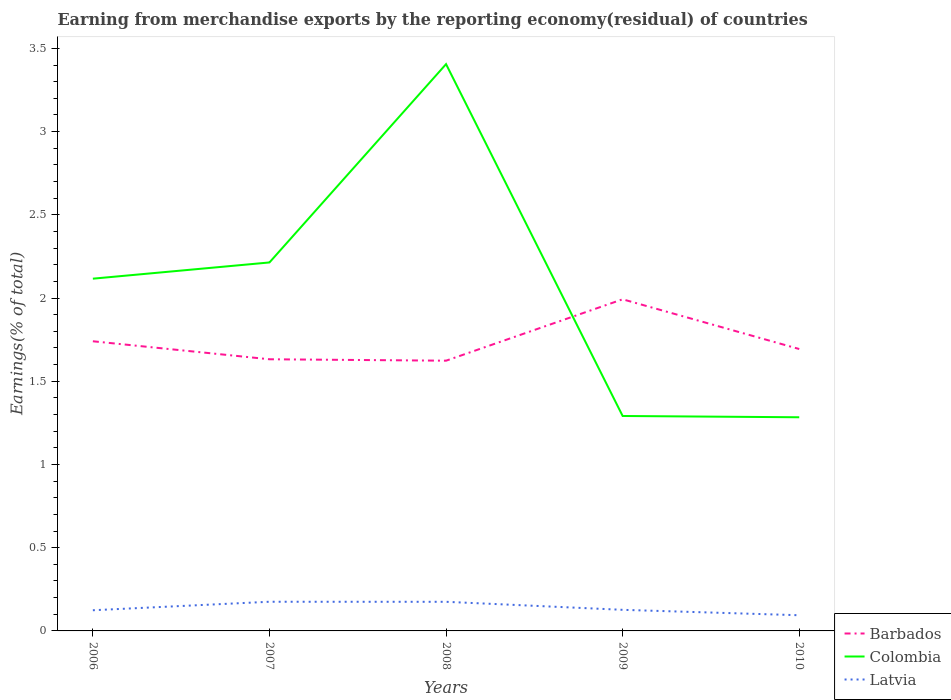How many different coloured lines are there?
Provide a short and direct response. 3. Is the number of lines equal to the number of legend labels?
Your response must be concise. Yes. Across all years, what is the maximum percentage of amount earned from merchandise exports in Colombia?
Your response must be concise. 1.28. In which year was the percentage of amount earned from merchandise exports in Latvia maximum?
Provide a succinct answer. 2010. What is the total percentage of amount earned from merchandise exports in Latvia in the graph?
Provide a short and direct response. -0. What is the difference between the highest and the second highest percentage of amount earned from merchandise exports in Colombia?
Provide a short and direct response. 2.12. What is the difference between the highest and the lowest percentage of amount earned from merchandise exports in Barbados?
Make the answer very short. 2. Does the graph contain grids?
Keep it short and to the point. No. How many legend labels are there?
Your answer should be compact. 3. How are the legend labels stacked?
Give a very brief answer. Vertical. What is the title of the graph?
Provide a short and direct response. Earning from merchandise exports by the reporting economy(residual) of countries. What is the label or title of the X-axis?
Provide a succinct answer. Years. What is the label or title of the Y-axis?
Make the answer very short. Earnings(% of total). What is the Earnings(% of total) in Barbados in 2006?
Keep it short and to the point. 1.74. What is the Earnings(% of total) in Colombia in 2006?
Ensure brevity in your answer.  2.12. What is the Earnings(% of total) of Latvia in 2006?
Your answer should be compact. 0.12. What is the Earnings(% of total) in Barbados in 2007?
Your answer should be compact. 1.63. What is the Earnings(% of total) in Colombia in 2007?
Provide a short and direct response. 2.21. What is the Earnings(% of total) of Latvia in 2007?
Offer a very short reply. 0.18. What is the Earnings(% of total) of Barbados in 2008?
Offer a very short reply. 1.62. What is the Earnings(% of total) of Colombia in 2008?
Your answer should be very brief. 3.41. What is the Earnings(% of total) in Latvia in 2008?
Provide a succinct answer. 0.17. What is the Earnings(% of total) in Barbados in 2009?
Provide a short and direct response. 1.99. What is the Earnings(% of total) in Colombia in 2009?
Offer a terse response. 1.29. What is the Earnings(% of total) in Latvia in 2009?
Offer a terse response. 0.13. What is the Earnings(% of total) in Barbados in 2010?
Give a very brief answer. 1.69. What is the Earnings(% of total) in Colombia in 2010?
Provide a short and direct response. 1.28. What is the Earnings(% of total) in Latvia in 2010?
Ensure brevity in your answer.  0.09. Across all years, what is the maximum Earnings(% of total) of Barbados?
Give a very brief answer. 1.99. Across all years, what is the maximum Earnings(% of total) of Colombia?
Provide a short and direct response. 3.41. Across all years, what is the maximum Earnings(% of total) of Latvia?
Ensure brevity in your answer.  0.18. Across all years, what is the minimum Earnings(% of total) of Barbados?
Offer a terse response. 1.62. Across all years, what is the minimum Earnings(% of total) in Colombia?
Give a very brief answer. 1.28. Across all years, what is the minimum Earnings(% of total) of Latvia?
Ensure brevity in your answer.  0.09. What is the total Earnings(% of total) of Barbados in the graph?
Your answer should be very brief. 8.68. What is the total Earnings(% of total) in Colombia in the graph?
Provide a succinct answer. 10.31. What is the total Earnings(% of total) in Latvia in the graph?
Offer a very short reply. 0.7. What is the difference between the Earnings(% of total) in Barbados in 2006 and that in 2007?
Provide a succinct answer. 0.11. What is the difference between the Earnings(% of total) of Colombia in 2006 and that in 2007?
Ensure brevity in your answer.  -0.1. What is the difference between the Earnings(% of total) of Latvia in 2006 and that in 2007?
Provide a succinct answer. -0.05. What is the difference between the Earnings(% of total) in Barbados in 2006 and that in 2008?
Make the answer very short. 0.12. What is the difference between the Earnings(% of total) in Colombia in 2006 and that in 2008?
Your answer should be compact. -1.29. What is the difference between the Earnings(% of total) of Latvia in 2006 and that in 2008?
Your response must be concise. -0.05. What is the difference between the Earnings(% of total) of Barbados in 2006 and that in 2009?
Give a very brief answer. -0.25. What is the difference between the Earnings(% of total) in Colombia in 2006 and that in 2009?
Your response must be concise. 0.82. What is the difference between the Earnings(% of total) in Latvia in 2006 and that in 2009?
Provide a short and direct response. -0. What is the difference between the Earnings(% of total) of Barbados in 2006 and that in 2010?
Your answer should be very brief. 0.05. What is the difference between the Earnings(% of total) in Colombia in 2006 and that in 2010?
Give a very brief answer. 0.83. What is the difference between the Earnings(% of total) in Latvia in 2006 and that in 2010?
Give a very brief answer. 0.03. What is the difference between the Earnings(% of total) of Barbados in 2007 and that in 2008?
Make the answer very short. 0.01. What is the difference between the Earnings(% of total) in Colombia in 2007 and that in 2008?
Your response must be concise. -1.19. What is the difference between the Earnings(% of total) of Latvia in 2007 and that in 2008?
Offer a terse response. 0. What is the difference between the Earnings(% of total) in Barbados in 2007 and that in 2009?
Keep it short and to the point. -0.36. What is the difference between the Earnings(% of total) in Colombia in 2007 and that in 2009?
Your response must be concise. 0.92. What is the difference between the Earnings(% of total) in Latvia in 2007 and that in 2009?
Provide a short and direct response. 0.05. What is the difference between the Earnings(% of total) of Barbados in 2007 and that in 2010?
Your response must be concise. -0.06. What is the difference between the Earnings(% of total) in Colombia in 2007 and that in 2010?
Make the answer very short. 0.93. What is the difference between the Earnings(% of total) of Latvia in 2007 and that in 2010?
Give a very brief answer. 0.08. What is the difference between the Earnings(% of total) in Barbados in 2008 and that in 2009?
Make the answer very short. -0.37. What is the difference between the Earnings(% of total) in Colombia in 2008 and that in 2009?
Provide a succinct answer. 2.11. What is the difference between the Earnings(% of total) of Latvia in 2008 and that in 2009?
Ensure brevity in your answer.  0.05. What is the difference between the Earnings(% of total) in Barbados in 2008 and that in 2010?
Your answer should be very brief. -0.07. What is the difference between the Earnings(% of total) of Colombia in 2008 and that in 2010?
Give a very brief answer. 2.12. What is the difference between the Earnings(% of total) in Latvia in 2008 and that in 2010?
Give a very brief answer. 0.08. What is the difference between the Earnings(% of total) of Barbados in 2009 and that in 2010?
Provide a short and direct response. 0.3. What is the difference between the Earnings(% of total) of Colombia in 2009 and that in 2010?
Provide a succinct answer. 0.01. What is the difference between the Earnings(% of total) of Latvia in 2009 and that in 2010?
Offer a terse response. 0.03. What is the difference between the Earnings(% of total) in Barbados in 2006 and the Earnings(% of total) in Colombia in 2007?
Provide a succinct answer. -0.47. What is the difference between the Earnings(% of total) in Barbados in 2006 and the Earnings(% of total) in Latvia in 2007?
Your answer should be very brief. 1.56. What is the difference between the Earnings(% of total) in Colombia in 2006 and the Earnings(% of total) in Latvia in 2007?
Ensure brevity in your answer.  1.94. What is the difference between the Earnings(% of total) of Barbados in 2006 and the Earnings(% of total) of Colombia in 2008?
Make the answer very short. -1.67. What is the difference between the Earnings(% of total) of Barbados in 2006 and the Earnings(% of total) of Latvia in 2008?
Give a very brief answer. 1.57. What is the difference between the Earnings(% of total) in Colombia in 2006 and the Earnings(% of total) in Latvia in 2008?
Offer a terse response. 1.94. What is the difference between the Earnings(% of total) of Barbados in 2006 and the Earnings(% of total) of Colombia in 2009?
Provide a short and direct response. 0.45. What is the difference between the Earnings(% of total) in Barbados in 2006 and the Earnings(% of total) in Latvia in 2009?
Ensure brevity in your answer.  1.61. What is the difference between the Earnings(% of total) of Colombia in 2006 and the Earnings(% of total) of Latvia in 2009?
Your answer should be very brief. 1.99. What is the difference between the Earnings(% of total) in Barbados in 2006 and the Earnings(% of total) in Colombia in 2010?
Provide a short and direct response. 0.46. What is the difference between the Earnings(% of total) in Barbados in 2006 and the Earnings(% of total) in Latvia in 2010?
Offer a terse response. 1.65. What is the difference between the Earnings(% of total) in Colombia in 2006 and the Earnings(% of total) in Latvia in 2010?
Offer a very short reply. 2.02. What is the difference between the Earnings(% of total) in Barbados in 2007 and the Earnings(% of total) in Colombia in 2008?
Make the answer very short. -1.77. What is the difference between the Earnings(% of total) of Barbados in 2007 and the Earnings(% of total) of Latvia in 2008?
Provide a succinct answer. 1.46. What is the difference between the Earnings(% of total) in Colombia in 2007 and the Earnings(% of total) in Latvia in 2008?
Your answer should be very brief. 2.04. What is the difference between the Earnings(% of total) of Barbados in 2007 and the Earnings(% of total) of Colombia in 2009?
Ensure brevity in your answer.  0.34. What is the difference between the Earnings(% of total) in Barbados in 2007 and the Earnings(% of total) in Latvia in 2009?
Ensure brevity in your answer.  1.51. What is the difference between the Earnings(% of total) in Colombia in 2007 and the Earnings(% of total) in Latvia in 2009?
Your answer should be very brief. 2.09. What is the difference between the Earnings(% of total) in Barbados in 2007 and the Earnings(% of total) in Colombia in 2010?
Offer a very short reply. 0.35. What is the difference between the Earnings(% of total) in Barbados in 2007 and the Earnings(% of total) in Latvia in 2010?
Give a very brief answer. 1.54. What is the difference between the Earnings(% of total) of Colombia in 2007 and the Earnings(% of total) of Latvia in 2010?
Your answer should be very brief. 2.12. What is the difference between the Earnings(% of total) in Barbados in 2008 and the Earnings(% of total) in Colombia in 2009?
Ensure brevity in your answer.  0.33. What is the difference between the Earnings(% of total) in Barbados in 2008 and the Earnings(% of total) in Latvia in 2009?
Your answer should be very brief. 1.5. What is the difference between the Earnings(% of total) in Colombia in 2008 and the Earnings(% of total) in Latvia in 2009?
Give a very brief answer. 3.28. What is the difference between the Earnings(% of total) in Barbados in 2008 and the Earnings(% of total) in Colombia in 2010?
Your answer should be compact. 0.34. What is the difference between the Earnings(% of total) in Barbados in 2008 and the Earnings(% of total) in Latvia in 2010?
Your answer should be very brief. 1.53. What is the difference between the Earnings(% of total) of Colombia in 2008 and the Earnings(% of total) of Latvia in 2010?
Give a very brief answer. 3.31. What is the difference between the Earnings(% of total) of Barbados in 2009 and the Earnings(% of total) of Colombia in 2010?
Your answer should be compact. 0.71. What is the difference between the Earnings(% of total) of Barbados in 2009 and the Earnings(% of total) of Latvia in 2010?
Make the answer very short. 1.9. What is the difference between the Earnings(% of total) in Colombia in 2009 and the Earnings(% of total) in Latvia in 2010?
Offer a very short reply. 1.2. What is the average Earnings(% of total) in Barbados per year?
Provide a short and direct response. 1.74. What is the average Earnings(% of total) of Colombia per year?
Offer a terse response. 2.06. What is the average Earnings(% of total) in Latvia per year?
Make the answer very short. 0.14. In the year 2006, what is the difference between the Earnings(% of total) in Barbados and Earnings(% of total) in Colombia?
Provide a short and direct response. -0.38. In the year 2006, what is the difference between the Earnings(% of total) of Barbados and Earnings(% of total) of Latvia?
Provide a short and direct response. 1.62. In the year 2006, what is the difference between the Earnings(% of total) in Colombia and Earnings(% of total) in Latvia?
Ensure brevity in your answer.  1.99. In the year 2007, what is the difference between the Earnings(% of total) of Barbados and Earnings(% of total) of Colombia?
Keep it short and to the point. -0.58. In the year 2007, what is the difference between the Earnings(% of total) of Barbados and Earnings(% of total) of Latvia?
Provide a short and direct response. 1.46. In the year 2007, what is the difference between the Earnings(% of total) of Colombia and Earnings(% of total) of Latvia?
Give a very brief answer. 2.04. In the year 2008, what is the difference between the Earnings(% of total) of Barbados and Earnings(% of total) of Colombia?
Your answer should be very brief. -1.78. In the year 2008, what is the difference between the Earnings(% of total) of Barbados and Earnings(% of total) of Latvia?
Make the answer very short. 1.45. In the year 2008, what is the difference between the Earnings(% of total) in Colombia and Earnings(% of total) in Latvia?
Provide a succinct answer. 3.23. In the year 2009, what is the difference between the Earnings(% of total) of Barbados and Earnings(% of total) of Colombia?
Provide a succinct answer. 0.7. In the year 2009, what is the difference between the Earnings(% of total) of Barbados and Earnings(% of total) of Latvia?
Offer a terse response. 1.87. In the year 2009, what is the difference between the Earnings(% of total) in Colombia and Earnings(% of total) in Latvia?
Your response must be concise. 1.16. In the year 2010, what is the difference between the Earnings(% of total) in Barbados and Earnings(% of total) in Colombia?
Offer a very short reply. 0.41. In the year 2010, what is the difference between the Earnings(% of total) of Barbados and Earnings(% of total) of Latvia?
Make the answer very short. 1.6. In the year 2010, what is the difference between the Earnings(% of total) in Colombia and Earnings(% of total) in Latvia?
Make the answer very short. 1.19. What is the ratio of the Earnings(% of total) in Barbados in 2006 to that in 2007?
Your response must be concise. 1.07. What is the ratio of the Earnings(% of total) of Colombia in 2006 to that in 2007?
Provide a succinct answer. 0.96. What is the ratio of the Earnings(% of total) of Latvia in 2006 to that in 2007?
Ensure brevity in your answer.  0.71. What is the ratio of the Earnings(% of total) in Barbados in 2006 to that in 2008?
Provide a succinct answer. 1.07. What is the ratio of the Earnings(% of total) of Colombia in 2006 to that in 2008?
Provide a short and direct response. 0.62. What is the ratio of the Earnings(% of total) of Latvia in 2006 to that in 2008?
Offer a very short reply. 0.71. What is the ratio of the Earnings(% of total) of Barbados in 2006 to that in 2009?
Make the answer very short. 0.87. What is the ratio of the Earnings(% of total) in Colombia in 2006 to that in 2009?
Offer a very short reply. 1.64. What is the ratio of the Earnings(% of total) of Latvia in 2006 to that in 2009?
Provide a short and direct response. 0.98. What is the ratio of the Earnings(% of total) in Barbados in 2006 to that in 2010?
Your answer should be compact. 1.03. What is the ratio of the Earnings(% of total) of Colombia in 2006 to that in 2010?
Give a very brief answer. 1.65. What is the ratio of the Earnings(% of total) of Latvia in 2006 to that in 2010?
Your response must be concise. 1.32. What is the ratio of the Earnings(% of total) of Barbados in 2007 to that in 2008?
Provide a short and direct response. 1.01. What is the ratio of the Earnings(% of total) in Colombia in 2007 to that in 2008?
Provide a short and direct response. 0.65. What is the ratio of the Earnings(% of total) in Latvia in 2007 to that in 2008?
Keep it short and to the point. 1. What is the ratio of the Earnings(% of total) of Barbados in 2007 to that in 2009?
Offer a very short reply. 0.82. What is the ratio of the Earnings(% of total) of Colombia in 2007 to that in 2009?
Your response must be concise. 1.71. What is the ratio of the Earnings(% of total) in Latvia in 2007 to that in 2009?
Your response must be concise. 1.38. What is the ratio of the Earnings(% of total) of Barbados in 2007 to that in 2010?
Provide a succinct answer. 0.96. What is the ratio of the Earnings(% of total) in Colombia in 2007 to that in 2010?
Offer a very short reply. 1.72. What is the ratio of the Earnings(% of total) of Latvia in 2007 to that in 2010?
Provide a short and direct response. 1.86. What is the ratio of the Earnings(% of total) of Barbados in 2008 to that in 2009?
Keep it short and to the point. 0.81. What is the ratio of the Earnings(% of total) in Colombia in 2008 to that in 2009?
Your answer should be compact. 2.64. What is the ratio of the Earnings(% of total) in Latvia in 2008 to that in 2009?
Your answer should be very brief. 1.38. What is the ratio of the Earnings(% of total) in Barbados in 2008 to that in 2010?
Provide a short and direct response. 0.96. What is the ratio of the Earnings(% of total) of Colombia in 2008 to that in 2010?
Ensure brevity in your answer.  2.65. What is the ratio of the Earnings(% of total) in Latvia in 2008 to that in 2010?
Provide a succinct answer. 1.86. What is the ratio of the Earnings(% of total) in Barbados in 2009 to that in 2010?
Provide a short and direct response. 1.18. What is the ratio of the Earnings(% of total) in Latvia in 2009 to that in 2010?
Your response must be concise. 1.34. What is the difference between the highest and the second highest Earnings(% of total) of Barbados?
Provide a succinct answer. 0.25. What is the difference between the highest and the second highest Earnings(% of total) in Colombia?
Provide a succinct answer. 1.19. What is the difference between the highest and the lowest Earnings(% of total) of Barbados?
Make the answer very short. 0.37. What is the difference between the highest and the lowest Earnings(% of total) in Colombia?
Provide a succinct answer. 2.12. What is the difference between the highest and the lowest Earnings(% of total) of Latvia?
Provide a succinct answer. 0.08. 